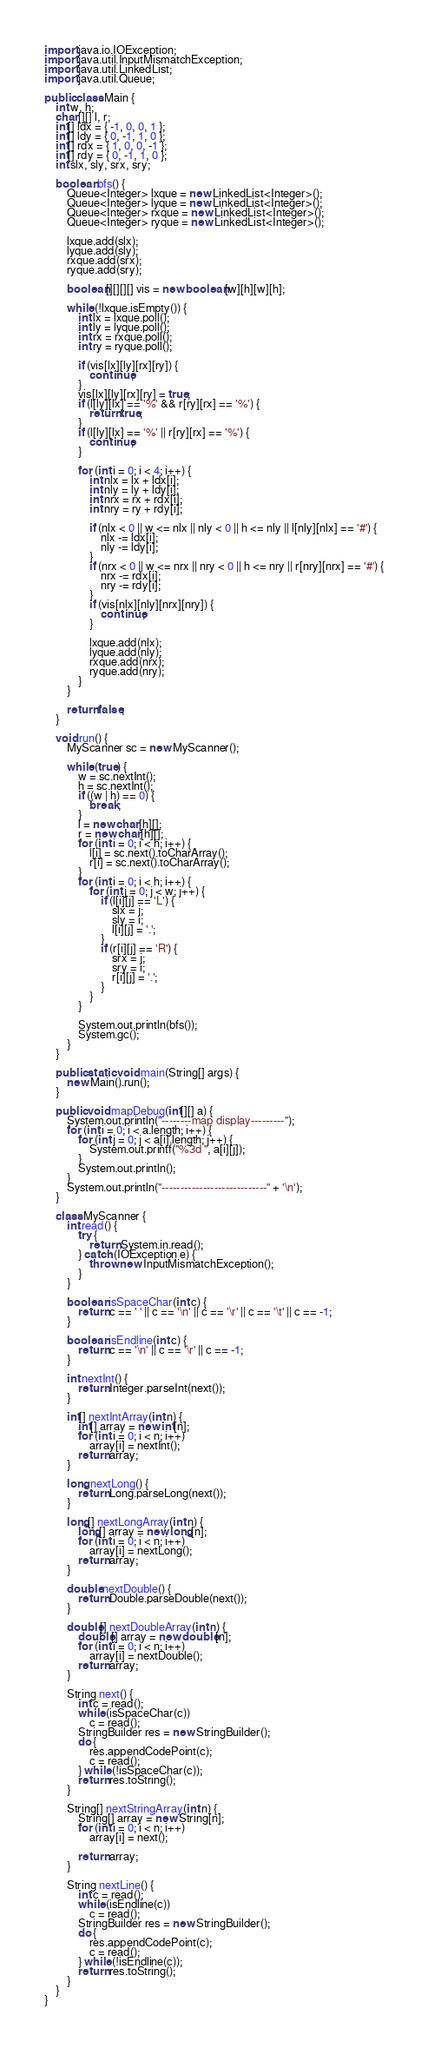<code> <loc_0><loc_0><loc_500><loc_500><_Java_>import java.io.IOException;
import java.util.InputMismatchException;
import java.util.LinkedList;
import java.util.Queue;

public class Main {
	int w, h;
	char[][] l, r;
	int[] ldx = { -1, 0, 0, 1 };
	int[] ldy = { 0, -1, 1, 0 };
	int[] rdx = { 1, 0, 0, -1 };
	int[] rdy = { 0, -1, 1, 0 };
	int slx, sly, srx, sry;

	boolean bfs() {
		Queue<Integer> lxque = new LinkedList<Integer>();
		Queue<Integer> lyque = new LinkedList<Integer>();
		Queue<Integer> rxque = new LinkedList<Integer>();
		Queue<Integer> ryque = new LinkedList<Integer>();

		lxque.add(slx);
		lyque.add(sly);
		rxque.add(srx);
		ryque.add(sry);

		boolean[][][][] vis = new boolean[w][h][w][h];

		while (!lxque.isEmpty()) {
			int lx = lxque.poll();
			int ly = lyque.poll();
			int rx = rxque.poll();
			int ry = ryque.poll();

			if (vis[lx][ly][rx][ry]) {
				continue;
			}
			vis[lx][ly][rx][ry] = true;
			if (l[ly][lx] == '%' && r[ry][rx] == '%') {
				return true;
			}
			if (l[ly][lx] == '%' || r[ry][rx] == '%') {
				continue;
			}

			for (int i = 0; i < 4; i++) {
				int nlx = lx + ldx[i];
				int nly = ly + ldy[i];
				int nrx = rx + rdx[i];
				int nry = ry + rdy[i];

				if (nlx < 0 || w <= nlx || nly < 0 || h <= nly || l[nly][nlx] == '#') {
					nlx -= ldx[i];
					nly -= ldy[i];
				}
				if (nrx < 0 || w <= nrx || nry < 0 || h <= nry || r[nry][nrx] == '#') {
					nrx -= rdx[i];
					nry -= rdy[i];
				}
				if (vis[nlx][nly][nrx][nry]) {
					continue;
				}

				lxque.add(nlx);
				lyque.add(nly);
				rxque.add(nrx);
				ryque.add(nry);
			}
		}

		return false;
	}

	void run() {
		MyScanner sc = new MyScanner();

		while (true) {
			w = sc.nextInt();
			h = sc.nextInt();
			if ((w | h) == 0) {
				break;
			}
			l = new char[h][];
			r = new char[h][];
			for (int i = 0; i < h; i++) {
				l[i] = sc.next().toCharArray();
				r[i] = sc.next().toCharArray();
			}
			for (int i = 0; i < h; i++) {
				for (int j = 0; j < w; j++) {
					if (l[i][j] == 'L') {
						slx = j;
						sly = i;
						l[i][j] = '.';
					}
					if (r[i][j] == 'R') {
						srx = j;
						sry = i;
						r[i][j] = '.';
					}
				}
			}

			System.out.println(bfs());
			System.gc();
		}
	}

	public static void main(String[] args) {
		new Main().run();
	}

	public void mapDebug(int[][] a) {
		System.out.println("--------map display---------");
		for (int i = 0; i < a.length; i++) {
			for (int j = 0; j < a[i].length; j++) {
				System.out.printf("%3d ", a[i][j]);
			}
			System.out.println();
		}
		System.out.println("----------------------------" + '\n');
	}

	class MyScanner {
		int read() {
			try {
				return System.in.read();
			} catch (IOException e) {
				throw new InputMismatchException();
			}
		}

		boolean isSpaceChar(int c) {
			return c == ' ' || c == '\n' || c == '\r' || c == '\t' || c == -1;
		}

		boolean isEndline(int c) {
			return c == '\n' || c == '\r' || c == -1;
		}

		int nextInt() {
			return Integer.parseInt(next());
		}

		int[] nextIntArray(int n) {
			int[] array = new int[n];
			for (int i = 0; i < n; i++)
				array[i] = nextInt();
			return array;
		}

		long nextLong() {
			return Long.parseLong(next());
		}

		long[] nextLongArray(int n) {
			long[] array = new long[n];
			for (int i = 0; i < n; i++)
				array[i] = nextLong();
			return array;
		}

		double nextDouble() {
			return Double.parseDouble(next());
		}

		double[] nextDoubleArray(int n) {
			double[] array = new double[n];
			for (int i = 0; i < n; i++)
				array[i] = nextDouble();
			return array;
		}

		String next() {
			int c = read();
			while (isSpaceChar(c))
				c = read();
			StringBuilder res = new StringBuilder();
			do {
				res.appendCodePoint(c);
				c = read();
			} while (!isSpaceChar(c));
			return res.toString();
		}

		String[] nextStringArray(int n) {
			String[] array = new String[n];
			for (int i = 0; i < n; i++)
				array[i] = next();

			return array;
		}

		String nextLine() {
			int c = read();
			while (isEndline(c))
				c = read();
			StringBuilder res = new StringBuilder();
			do {
				res.appendCodePoint(c);
				c = read();
			} while (!isEndline(c));
			return res.toString();
		}
	}
}</code> 